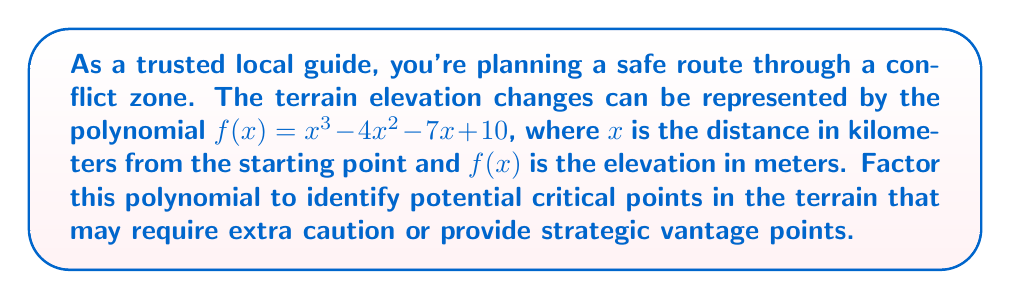Can you solve this math problem? To factor the polynomial $f(x) = x^3 - 4x^2 - 7x + 10$, we'll follow these steps:

1) First, let's check if there are any rational roots using the rational root theorem. The possible rational roots are the factors of the constant term: ±1, ±2, ±5, ±10.

2) Testing these values, we find that $f(1) = 0$. So $(x-1)$ is a factor.

3) We can use polynomial long division to divide $f(x)$ by $(x-1)$:

   $$x^3 - 4x^2 - 7x + 10 = (x-1)(x^2 - 3x - 10)$$

4) Now we need to factor the quadratic $x^2 - 3x - 10$. We can do this by finding two numbers that multiply to give -10 and add to give -3. These numbers are -5 and 2.

5) Therefore, $x^2 - 3x - 10 = (x-5)(x+2)$

6) Combining all factors, we get:

   $$f(x) = (x-1)(x-5)(x+2)$$

This factorization reveals three critical points in the terrain: at 1 km, 5 km, and -2 km from the starting point. The -2 km point is not physically meaningful in this context, but the points at 1 km and 5 km represent locations where the elevation could change significantly, potentially offering strategic positions or requiring extra caution.
Answer: $f(x) = (x-1)(x-5)(x+2)$ 